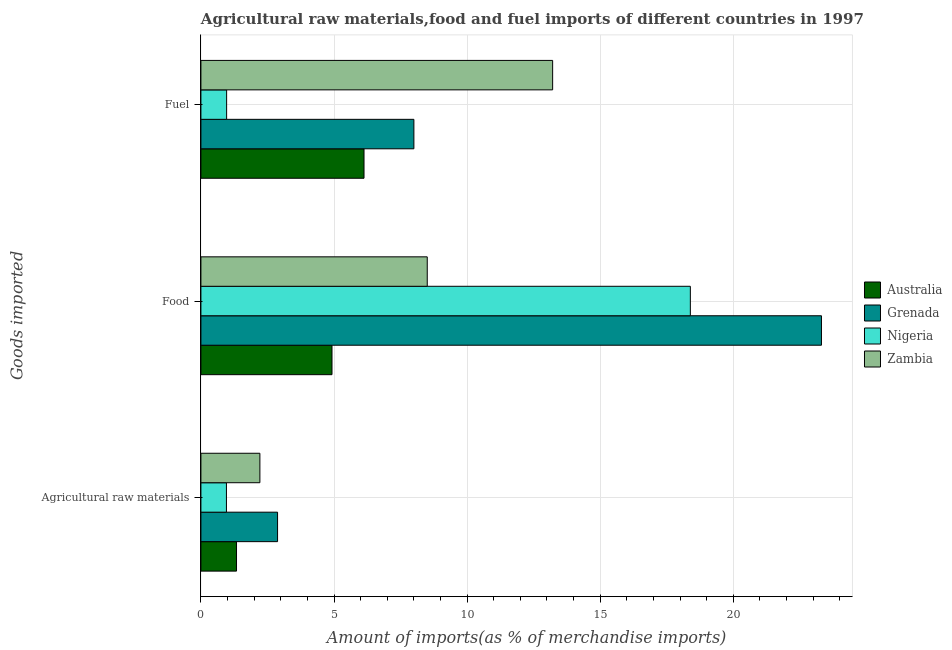How many different coloured bars are there?
Your answer should be compact. 4. Are the number of bars per tick equal to the number of legend labels?
Your response must be concise. Yes. How many bars are there on the 2nd tick from the top?
Provide a succinct answer. 4. How many bars are there on the 2nd tick from the bottom?
Make the answer very short. 4. What is the label of the 1st group of bars from the top?
Offer a very short reply. Fuel. What is the percentage of raw materials imports in Australia?
Give a very brief answer. 1.34. Across all countries, what is the maximum percentage of raw materials imports?
Your answer should be very brief. 2.88. Across all countries, what is the minimum percentage of fuel imports?
Provide a succinct answer. 0.97. In which country was the percentage of food imports maximum?
Keep it short and to the point. Grenada. In which country was the percentage of raw materials imports minimum?
Your answer should be very brief. Nigeria. What is the total percentage of raw materials imports in the graph?
Offer a very short reply. 7.39. What is the difference between the percentage of fuel imports in Grenada and that in Australia?
Give a very brief answer. 1.87. What is the difference between the percentage of food imports in Zambia and the percentage of raw materials imports in Grenada?
Your response must be concise. 5.62. What is the average percentage of raw materials imports per country?
Offer a terse response. 1.85. What is the difference between the percentage of food imports and percentage of fuel imports in Nigeria?
Ensure brevity in your answer.  17.42. In how many countries, is the percentage of fuel imports greater than 4 %?
Make the answer very short. 3. What is the ratio of the percentage of raw materials imports in Zambia to that in Grenada?
Make the answer very short. 0.77. Is the difference between the percentage of fuel imports in Grenada and Australia greater than the difference between the percentage of raw materials imports in Grenada and Australia?
Offer a terse response. Yes. What is the difference between the highest and the second highest percentage of raw materials imports?
Your answer should be very brief. 0.66. What is the difference between the highest and the lowest percentage of fuel imports?
Give a very brief answer. 12.25. Is the sum of the percentage of food imports in Zambia and Australia greater than the maximum percentage of raw materials imports across all countries?
Provide a short and direct response. Yes. What does the 2nd bar from the top in Fuel represents?
Your response must be concise. Nigeria. What does the 4th bar from the bottom in Agricultural raw materials represents?
Your answer should be compact. Zambia. Is it the case that in every country, the sum of the percentage of raw materials imports and percentage of food imports is greater than the percentage of fuel imports?
Ensure brevity in your answer.  No. How many bars are there?
Give a very brief answer. 12. Are all the bars in the graph horizontal?
Provide a succinct answer. Yes. What is the difference between two consecutive major ticks on the X-axis?
Make the answer very short. 5. Does the graph contain any zero values?
Make the answer very short. No. Where does the legend appear in the graph?
Your answer should be very brief. Center right. How many legend labels are there?
Your answer should be very brief. 4. How are the legend labels stacked?
Your answer should be compact. Vertical. What is the title of the graph?
Keep it short and to the point. Agricultural raw materials,food and fuel imports of different countries in 1997. Does "Benin" appear as one of the legend labels in the graph?
Provide a succinct answer. No. What is the label or title of the X-axis?
Provide a succinct answer. Amount of imports(as % of merchandise imports). What is the label or title of the Y-axis?
Ensure brevity in your answer.  Goods imported. What is the Amount of imports(as % of merchandise imports) of Australia in Agricultural raw materials?
Provide a short and direct response. 1.34. What is the Amount of imports(as % of merchandise imports) in Grenada in Agricultural raw materials?
Your response must be concise. 2.88. What is the Amount of imports(as % of merchandise imports) in Nigeria in Agricultural raw materials?
Give a very brief answer. 0.96. What is the Amount of imports(as % of merchandise imports) of Zambia in Agricultural raw materials?
Keep it short and to the point. 2.22. What is the Amount of imports(as % of merchandise imports) of Australia in Food?
Give a very brief answer. 4.92. What is the Amount of imports(as % of merchandise imports) of Grenada in Food?
Offer a very short reply. 23.31. What is the Amount of imports(as % of merchandise imports) of Nigeria in Food?
Your answer should be very brief. 18.39. What is the Amount of imports(as % of merchandise imports) in Zambia in Food?
Offer a very short reply. 8.5. What is the Amount of imports(as % of merchandise imports) of Australia in Fuel?
Offer a terse response. 6.13. What is the Amount of imports(as % of merchandise imports) of Grenada in Fuel?
Your answer should be very brief. 8. What is the Amount of imports(as % of merchandise imports) of Nigeria in Fuel?
Your answer should be compact. 0.97. What is the Amount of imports(as % of merchandise imports) in Zambia in Fuel?
Ensure brevity in your answer.  13.21. Across all Goods imported, what is the maximum Amount of imports(as % of merchandise imports) of Australia?
Your response must be concise. 6.13. Across all Goods imported, what is the maximum Amount of imports(as % of merchandise imports) in Grenada?
Provide a succinct answer. 23.31. Across all Goods imported, what is the maximum Amount of imports(as % of merchandise imports) of Nigeria?
Your answer should be compact. 18.39. Across all Goods imported, what is the maximum Amount of imports(as % of merchandise imports) in Zambia?
Give a very brief answer. 13.21. Across all Goods imported, what is the minimum Amount of imports(as % of merchandise imports) of Australia?
Your response must be concise. 1.34. Across all Goods imported, what is the minimum Amount of imports(as % of merchandise imports) in Grenada?
Keep it short and to the point. 2.88. Across all Goods imported, what is the minimum Amount of imports(as % of merchandise imports) in Nigeria?
Provide a succinct answer. 0.96. Across all Goods imported, what is the minimum Amount of imports(as % of merchandise imports) in Zambia?
Your answer should be very brief. 2.22. What is the total Amount of imports(as % of merchandise imports) in Australia in the graph?
Your answer should be compact. 12.39. What is the total Amount of imports(as % of merchandise imports) of Grenada in the graph?
Give a very brief answer. 34.19. What is the total Amount of imports(as % of merchandise imports) in Nigeria in the graph?
Your answer should be compact. 20.31. What is the total Amount of imports(as % of merchandise imports) in Zambia in the graph?
Provide a succinct answer. 23.93. What is the difference between the Amount of imports(as % of merchandise imports) in Australia in Agricultural raw materials and that in Food?
Your answer should be compact. -3.59. What is the difference between the Amount of imports(as % of merchandise imports) of Grenada in Agricultural raw materials and that in Food?
Offer a terse response. -20.43. What is the difference between the Amount of imports(as % of merchandise imports) in Nigeria in Agricultural raw materials and that in Food?
Make the answer very short. -17.43. What is the difference between the Amount of imports(as % of merchandise imports) of Zambia in Agricultural raw materials and that in Food?
Give a very brief answer. -6.29. What is the difference between the Amount of imports(as % of merchandise imports) in Australia in Agricultural raw materials and that in Fuel?
Your answer should be very brief. -4.79. What is the difference between the Amount of imports(as % of merchandise imports) in Grenada in Agricultural raw materials and that in Fuel?
Your answer should be compact. -5.12. What is the difference between the Amount of imports(as % of merchandise imports) in Nigeria in Agricultural raw materials and that in Fuel?
Your answer should be very brief. -0.01. What is the difference between the Amount of imports(as % of merchandise imports) of Zambia in Agricultural raw materials and that in Fuel?
Your answer should be compact. -11. What is the difference between the Amount of imports(as % of merchandise imports) of Australia in Food and that in Fuel?
Ensure brevity in your answer.  -1.2. What is the difference between the Amount of imports(as % of merchandise imports) of Grenada in Food and that in Fuel?
Offer a very short reply. 15.31. What is the difference between the Amount of imports(as % of merchandise imports) in Nigeria in Food and that in Fuel?
Offer a terse response. 17.42. What is the difference between the Amount of imports(as % of merchandise imports) of Zambia in Food and that in Fuel?
Make the answer very short. -4.71. What is the difference between the Amount of imports(as % of merchandise imports) of Australia in Agricultural raw materials and the Amount of imports(as % of merchandise imports) of Grenada in Food?
Your answer should be very brief. -21.97. What is the difference between the Amount of imports(as % of merchandise imports) in Australia in Agricultural raw materials and the Amount of imports(as % of merchandise imports) in Nigeria in Food?
Provide a short and direct response. -17.05. What is the difference between the Amount of imports(as % of merchandise imports) of Australia in Agricultural raw materials and the Amount of imports(as % of merchandise imports) of Zambia in Food?
Your answer should be compact. -7.17. What is the difference between the Amount of imports(as % of merchandise imports) of Grenada in Agricultural raw materials and the Amount of imports(as % of merchandise imports) of Nigeria in Food?
Keep it short and to the point. -15.51. What is the difference between the Amount of imports(as % of merchandise imports) in Grenada in Agricultural raw materials and the Amount of imports(as % of merchandise imports) in Zambia in Food?
Keep it short and to the point. -5.62. What is the difference between the Amount of imports(as % of merchandise imports) of Nigeria in Agricultural raw materials and the Amount of imports(as % of merchandise imports) of Zambia in Food?
Offer a terse response. -7.54. What is the difference between the Amount of imports(as % of merchandise imports) of Australia in Agricultural raw materials and the Amount of imports(as % of merchandise imports) of Grenada in Fuel?
Offer a very short reply. -6.66. What is the difference between the Amount of imports(as % of merchandise imports) of Australia in Agricultural raw materials and the Amount of imports(as % of merchandise imports) of Nigeria in Fuel?
Provide a succinct answer. 0.37. What is the difference between the Amount of imports(as % of merchandise imports) in Australia in Agricultural raw materials and the Amount of imports(as % of merchandise imports) in Zambia in Fuel?
Keep it short and to the point. -11.88. What is the difference between the Amount of imports(as % of merchandise imports) in Grenada in Agricultural raw materials and the Amount of imports(as % of merchandise imports) in Nigeria in Fuel?
Your answer should be very brief. 1.91. What is the difference between the Amount of imports(as % of merchandise imports) in Grenada in Agricultural raw materials and the Amount of imports(as % of merchandise imports) in Zambia in Fuel?
Your answer should be very brief. -10.33. What is the difference between the Amount of imports(as % of merchandise imports) in Nigeria in Agricultural raw materials and the Amount of imports(as % of merchandise imports) in Zambia in Fuel?
Your answer should be very brief. -12.26. What is the difference between the Amount of imports(as % of merchandise imports) in Australia in Food and the Amount of imports(as % of merchandise imports) in Grenada in Fuel?
Keep it short and to the point. -3.08. What is the difference between the Amount of imports(as % of merchandise imports) of Australia in Food and the Amount of imports(as % of merchandise imports) of Nigeria in Fuel?
Make the answer very short. 3.96. What is the difference between the Amount of imports(as % of merchandise imports) in Australia in Food and the Amount of imports(as % of merchandise imports) in Zambia in Fuel?
Your answer should be compact. -8.29. What is the difference between the Amount of imports(as % of merchandise imports) in Grenada in Food and the Amount of imports(as % of merchandise imports) in Nigeria in Fuel?
Keep it short and to the point. 22.35. What is the difference between the Amount of imports(as % of merchandise imports) in Grenada in Food and the Amount of imports(as % of merchandise imports) in Zambia in Fuel?
Give a very brief answer. 10.1. What is the difference between the Amount of imports(as % of merchandise imports) of Nigeria in Food and the Amount of imports(as % of merchandise imports) of Zambia in Fuel?
Make the answer very short. 5.17. What is the average Amount of imports(as % of merchandise imports) in Australia per Goods imported?
Your answer should be very brief. 4.13. What is the average Amount of imports(as % of merchandise imports) in Grenada per Goods imported?
Your answer should be compact. 11.4. What is the average Amount of imports(as % of merchandise imports) in Nigeria per Goods imported?
Make the answer very short. 6.77. What is the average Amount of imports(as % of merchandise imports) of Zambia per Goods imported?
Provide a short and direct response. 7.98. What is the difference between the Amount of imports(as % of merchandise imports) of Australia and Amount of imports(as % of merchandise imports) of Grenada in Agricultural raw materials?
Provide a succinct answer. -1.54. What is the difference between the Amount of imports(as % of merchandise imports) in Australia and Amount of imports(as % of merchandise imports) in Nigeria in Agricultural raw materials?
Your answer should be compact. 0.38. What is the difference between the Amount of imports(as % of merchandise imports) in Australia and Amount of imports(as % of merchandise imports) in Zambia in Agricultural raw materials?
Make the answer very short. -0.88. What is the difference between the Amount of imports(as % of merchandise imports) of Grenada and Amount of imports(as % of merchandise imports) of Nigeria in Agricultural raw materials?
Offer a terse response. 1.92. What is the difference between the Amount of imports(as % of merchandise imports) of Grenada and Amount of imports(as % of merchandise imports) of Zambia in Agricultural raw materials?
Your answer should be compact. 0.66. What is the difference between the Amount of imports(as % of merchandise imports) of Nigeria and Amount of imports(as % of merchandise imports) of Zambia in Agricultural raw materials?
Provide a short and direct response. -1.26. What is the difference between the Amount of imports(as % of merchandise imports) of Australia and Amount of imports(as % of merchandise imports) of Grenada in Food?
Keep it short and to the point. -18.39. What is the difference between the Amount of imports(as % of merchandise imports) in Australia and Amount of imports(as % of merchandise imports) in Nigeria in Food?
Your response must be concise. -13.46. What is the difference between the Amount of imports(as % of merchandise imports) of Australia and Amount of imports(as % of merchandise imports) of Zambia in Food?
Give a very brief answer. -3.58. What is the difference between the Amount of imports(as % of merchandise imports) in Grenada and Amount of imports(as % of merchandise imports) in Nigeria in Food?
Provide a succinct answer. 4.93. What is the difference between the Amount of imports(as % of merchandise imports) of Grenada and Amount of imports(as % of merchandise imports) of Zambia in Food?
Provide a short and direct response. 14.81. What is the difference between the Amount of imports(as % of merchandise imports) of Nigeria and Amount of imports(as % of merchandise imports) of Zambia in Food?
Offer a very short reply. 9.88. What is the difference between the Amount of imports(as % of merchandise imports) in Australia and Amount of imports(as % of merchandise imports) in Grenada in Fuel?
Provide a succinct answer. -1.87. What is the difference between the Amount of imports(as % of merchandise imports) of Australia and Amount of imports(as % of merchandise imports) of Nigeria in Fuel?
Your answer should be very brief. 5.16. What is the difference between the Amount of imports(as % of merchandise imports) of Australia and Amount of imports(as % of merchandise imports) of Zambia in Fuel?
Your response must be concise. -7.09. What is the difference between the Amount of imports(as % of merchandise imports) of Grenada and Amount of imports(as % of merchandise imports) of Nigeria in Fuel?
Your answer should be compact. 7.04. What is the difference between the Amount of imports(as % of merchandise imports) in Grenada and Amount of imports(as % of merchandise imports) in Zambia in Fuel?
Your answer should be very brief. -5.21. What is the difference between the Amount of imports(as % of merchandise imports) of Nigeria and Amount of imports(as % of merchandise imports) of Zambia in Fuel?
Make the answer very short. -12.25. What is the ratio of the Amount of imports(as % of merchandise imports) of Australia in Agricultural raw materials to that in Food?
Give a very brief answer. 0.27. What is the ratio of the Amount of imports(as % of merchandise imports) of Grenada in Agricultural raw materials to that in Food?
Your response must be concise. 0.12. What is the ratio of the Amount of imports(as % of merchandise imports) in Nigeria in Agricultural raw materials to that in Food?
Provide a succinct answer. 0.05. What is the ratio of the Amount of imports(as % of merchandise imports) of Zambia in Agricultural raw materials to that in Food?
Your answer should be compact. 0.26. What is the ratio of the Amount of imports(as % of merchandise imports) in Australia in Agricultural raw materials to that in Fuel?
Make the answer very short. 0.22. What is the ratio of the Amount of imports(as % of merchandise imports) in Grenada in Agricultural raw materials to that in Fuel?
Ensure brevity in your answer.  0.36. What is the ratio of the Amount of imports(as % of merchandise imports) of Zambia in Agricultural raw materials to that in Fuel?
Make the answer very short. 0.17. What is the ratio of the Amount of imports(as % of merchandise imports) of Australia in Food to that in Fuel?
Ensure brevity in your answer.  0.8. What is the ratio of the Amount of imports(as % of merchandise imports) of Grenada in Food to that in Fuel?
Ensure brevity in your answer.  2.91. What is the ratio of the Amount of imports(as % of merchandise imports) of Nigeria in Food to that in Fuel?
Provide a short and direct response. 19.04. What is the ratio of the Amount of imports(as % of merchandise imports) of Zambia in Food to that in Fuel?
Keep it short and to the point. 0.64. What is the difference between the highest and the second highest Amount of imports(as % of merchandise imports) in Australia?
Make the answer very short. 1.2. What is the difference between the highest and the second highest Amount of imports(as % of merchandise imports) in Grenada?
Your answer should be very brief. 15.31. What is the difference between the highest and the second highest Amount of imports(as % of merchandise imports) of Nigeria?
Provide a succinct answer. 17.42. What is the difference between the highest and the second highest Amount of imports(as % of merchandise imports) in Zambia?
Provide a succinct answer. 4.71. What is the difference between the highest and the lowest Amount of imports(as % of merchandise imports) in Australia?
Offer a terse response. 4.79. What is the difference between the highest and the lowest Amount of imports(as % of merchandise imports) of Grenada?
Your response must be concise. 20.43. What is the difference between the highest and the lowest Amount of imports(as % of merchandise imports) in Nigeria?
Keep it short and to the point. 17.43. What is the difference between the highest and the lowest Amount of imports(as % of merchandise imports) of Zambia?
Ensure brevity in your answer.  11. 